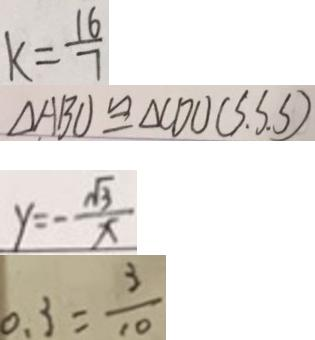<formula> <loc_0><loc_0><loc_500><loc_500>k = \frac { 1 6 } { 7 } 
 \Delta A B O \cong \Delta C D O ( S . S . S ) 
 y = - \frac { \sqrt { 3 } } { x } 
 0 . 3 = \frac { 3 } { 1 0 }</formula> 